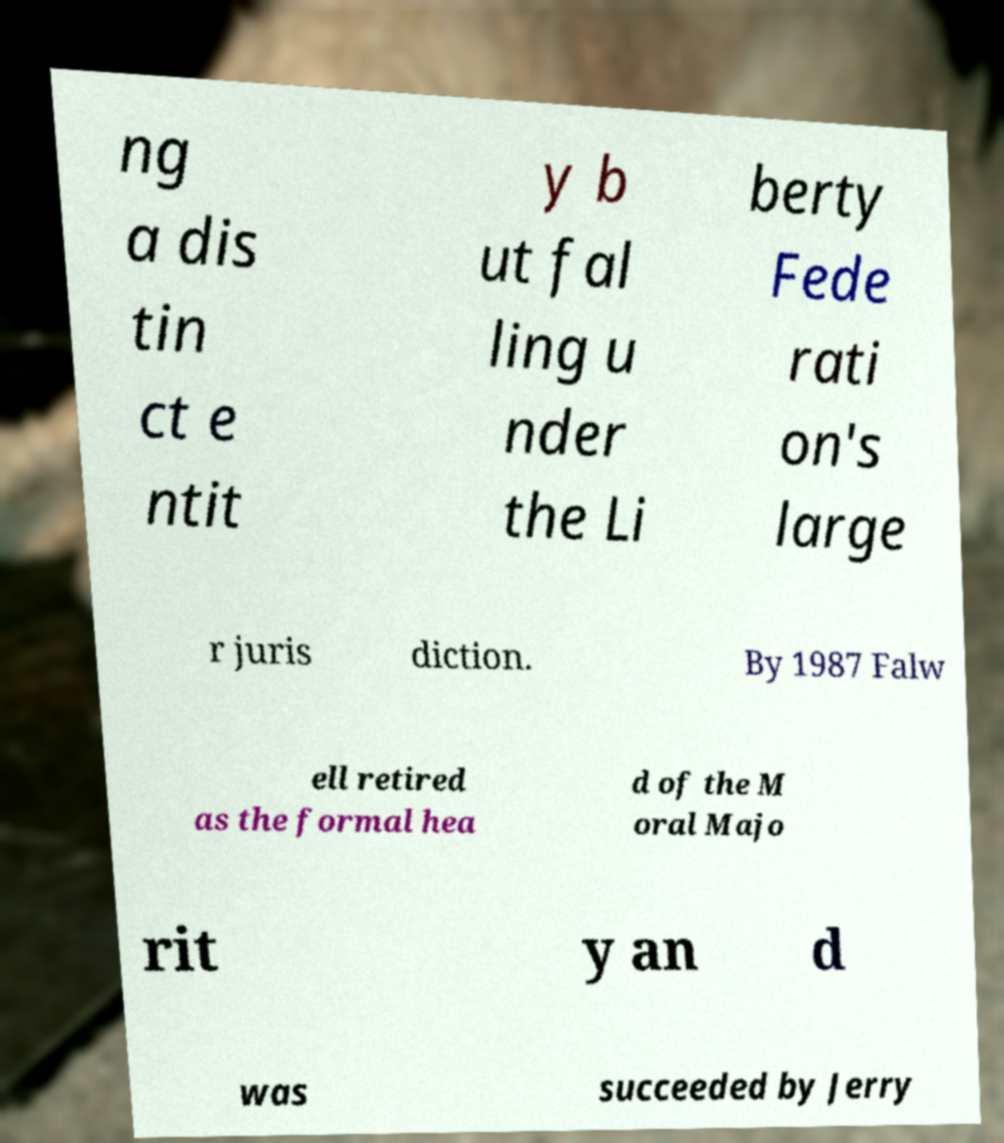What messages or text are displayed in this image? I need them in a readable, typed format. ng a dis tin ct e ntit y b ut fal ling u nder the Li berty Fede rati on's large r juris diction. By 1987 Falw ell retired as the formal hea d of the M oral Majo rit y an d was succeeded by Jerry 